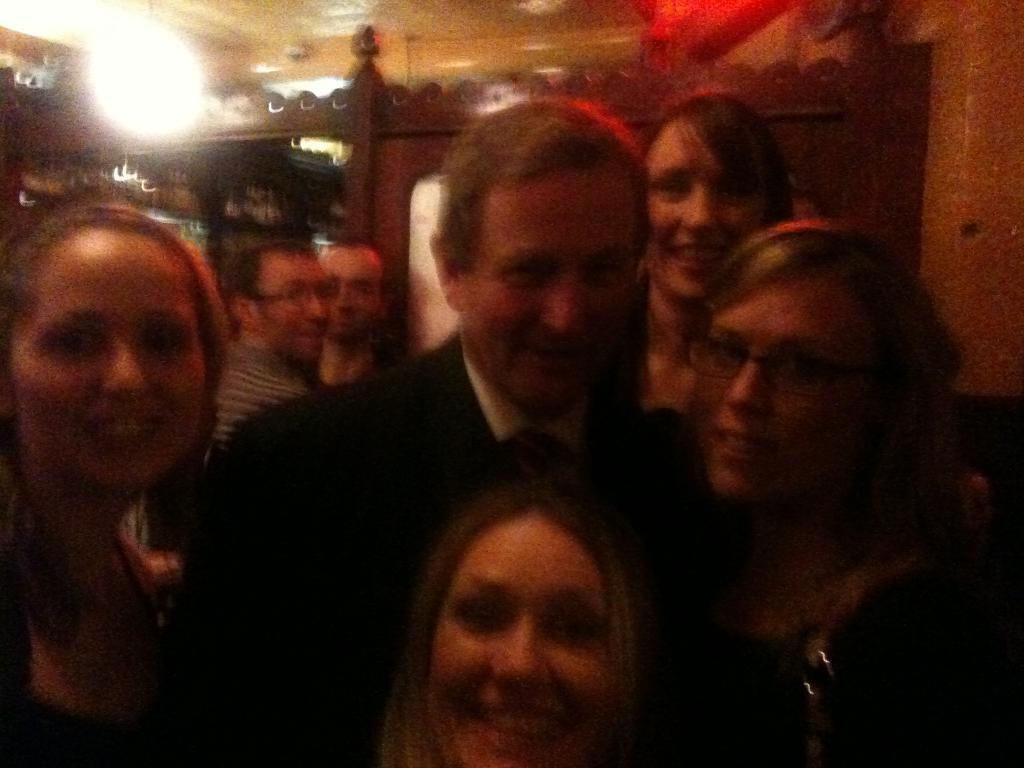What can be seen in the foreground of the image? There are people standing in the foreground of the image. What is present in the background of the image? There are men, light, a door, and other objects in the background of the image. Can you describe the people in the foreground? The facts provided do not give specific details about the people in the foreground. What might the door in the background lead to? The facts provided do not give information about the purpose or location of the door. What type of canvas is being used by the skateboarder in the image? There is no skateboarder or canvas present in the image. How does the earthquake affect the people in the image? There is no earthquake present in the image; the people are standing calmly. 